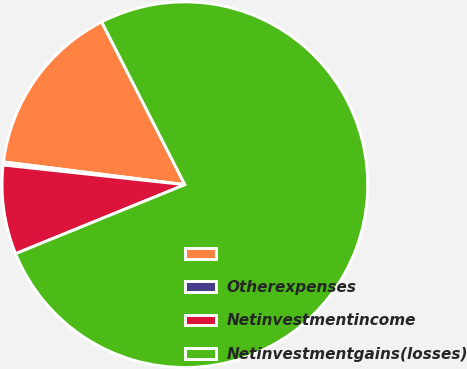<chart> <loc_0><loc_0><loc_500><loc_500><pie_chart><ecel><fcel>Otherexpenses<fcel>Netinvestmentincome<fcel>Netinvestmentgains(losses)<nl><fcel>15.49%<fcel>0.27%<fcel>7.88%<fcel>76.35%<nl></chart> 